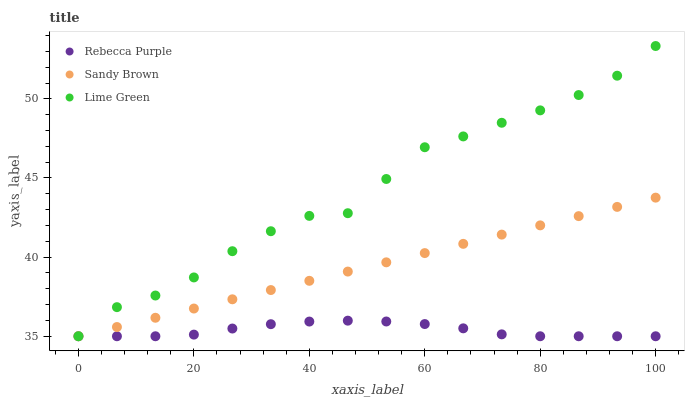Does Rebecca Purple have the minimum area under the curve?
Answer yes or no. Yes. Does Lime Green have the maximum area under the curve?
Answer yes or no. Yes. Does Sandy Brown have the minimum area under the curve?
Answer yes or no. No. Does Sandy Brown have the maximum area under the curve?
Answer yes or no. No. Is Sandy Brown the smoothest?
Answer yes or no. Yes. Is Lime Green the roughest?
Answer yes or no. Yes. Is Rebecca Purple the smoothest?
Answer yes or no. No. Is Rebecca Purple the roughest?
Answer yes or no. No. Does Lime Green have the lowest value?
Answer yes or no. Yes. Does Lime Green have the highest value?
Answer yes or no. Yes. Does Sandy Brown have the highest value?
Answer yes or no. No. Does Sandy Brown intersect Lime Green?
Answer yes or no. Yes. Is Sandy Brown less than Lime Green?
Answer yes or no. No. Is Sandy Brown greater than Lime Green?
Answer yes or no. No. 